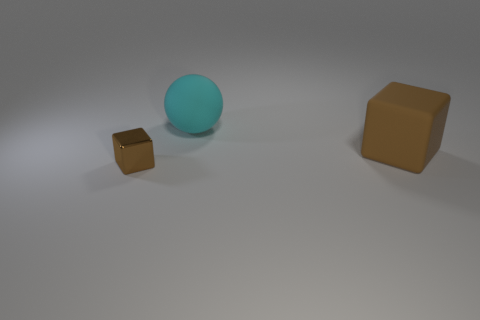Add 1 brown cubes. How many objects exist? 4 Subtract 1 cubes. How many cubes are left? 1 Subtract all cubes. How many objects are left? 1 Subtract all green balls. Subtract all brown cubes. How many balls are left? 1 Add 3 large rubber cubes. How many large rubber cubes exist? 4 Subtract 1 brown blocks. How many objects are left? 2 Subtract all yellow cubes. How many yellow spheres are left? 0 Subtract all cyan rubber balls. Subtract all small shiny objects. How many objects are left? 1 Add 3 brown blocks. How many brown blocks are left? 5 